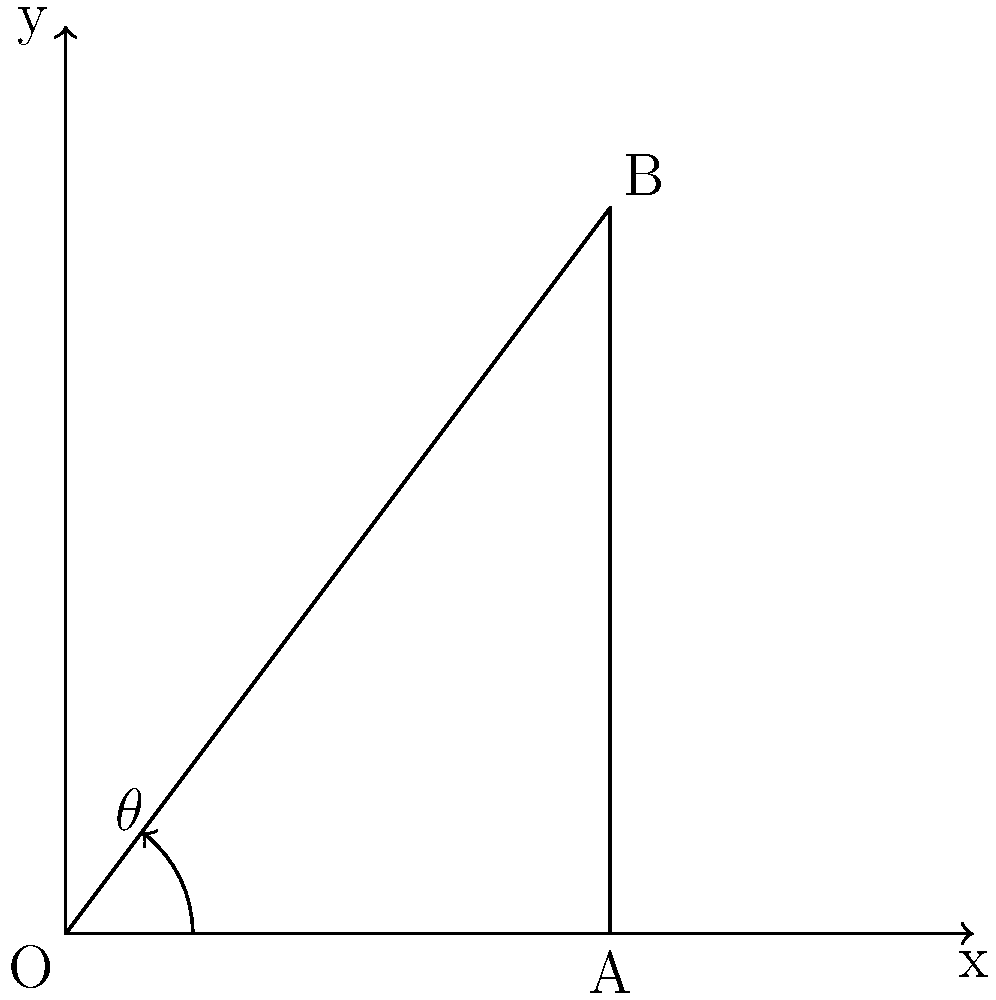In a 2D platformer game, you're implementing a projectile launching system. The player character is at point O(0,0) and needs to hit a target at point B(3,4). What should be the angle $\theta$ (in degrees) of the projectile's trajectory to hit the target accurately? To solve this problem, we'll use basic trigonometry:

1. First, identify the right triangle formed by points O, A, and B.
2. The adjacent side (OA) is the x-coordinate of point B: 3 units.
3. The opposite side (AB) is the y-coordinate of point B: 4 units.
4. To find the angle $\theta$, we use the arctangent function:

   $\theta = \arctan(\frac{\text{opposite}}{\text{adjacent}})$

5. Substituting the values:

   $\theta = \arctan(\frac{4}{3})$

6. Calculate this value:

   $\theta \approx 0.9272952180016122$ radians

7. Convert radians to degrees:

   $\theta \text{ in degrees} = 0.9272952180016122 \times \frac{180}{\pi} \approx 53.13010235415598°$

8. Round to two decimal places for practical use in game development:

   $\theta \approx 53.13°$
Answer: $53.13°$ 